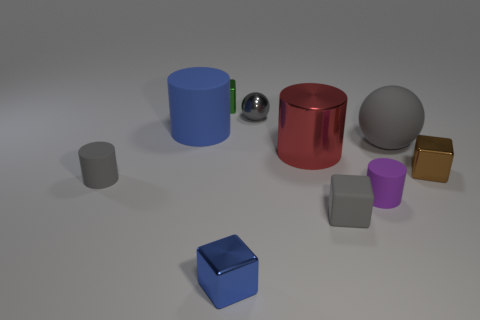Is the metallic cylinder the same color as the matte cube?
Make the answer very short. No. What is the material of the small gray thing behind the big matte thing to the left of the small gray shiny thing behind the gray matte cube?
Offer a terse response. Metal. There is a tiny blue object; are there any red things behind it?
Keep it short and to the point. Yes. The blue rubber object that is the same size as the red cylinder is what shape?
Provide a succinct answer. Cylinder. Is the blue cylinder made of the same material as the green block?
Keep it short and to the point. No. What number of matte objects are either small green cylinders or tiny blue objects?
Keep it short and to the point. 0. What shape is the small thing that is the same color as the large rubber cylinder?
Provide a short and direct response. Cube. There is a block behind the large ball; does it have the same color as the big matte ball?
Provide a succinct answer. No. There is a tiny gray rubber thing that is to the left of the big thing that is left of the tiny green metallic cube; what is its shape?
Offer a very short reply. Cylinder. How many objects are either big red things that are in front of the large gray sphere or gray spheres that are on the left side of the large red metallic thing?
Give a very brief answer. 2. 